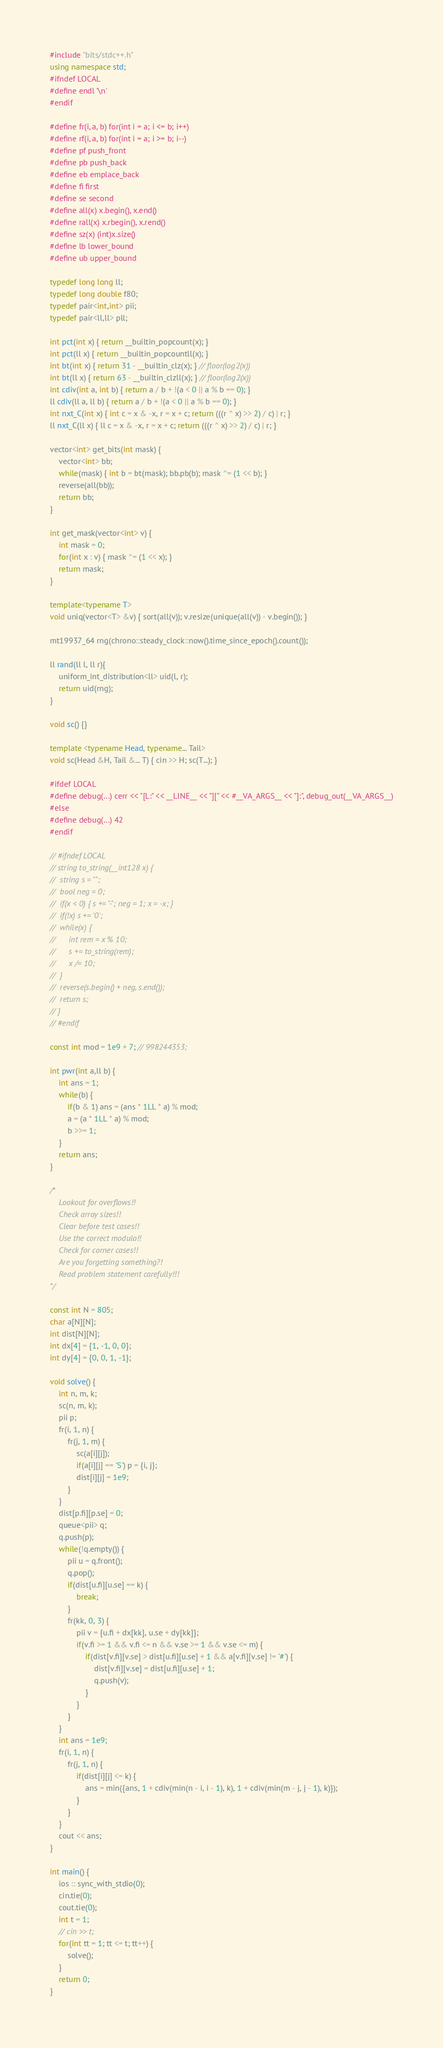Convert code to text. <code><loc_0><loc_0><loc_500><loc_500><_C++_>#include "bits/stdc++.h"
using namespace std;
#ifndef LOCAL
#define endl '\n'
#endif

#define fr(i, a, b) for(int i = a; i <= b; i++)
#define rf(i, a, b) for(int i = a; i >= b; i--)
#define pf push_front
#define pb push_back
#define eb emplace_back
#define fi first
#define se second
#define all(x) x.begin(), x.end()
#define rall(x) x.rbegin(), x.rend()
#define sz(x) (int)x.size()
#define lb lower_bound
#define ub upper_bound

typedef long long ll;
typedef long double f80;
typedef pair<int,int> pii;
typedef pair<ll,ll> pll;

int pct(int x) { return __builtin_popcount(x); }
int pct(ll x) { return __builtin_popcountll(x); }
int bt(int x) { return 31 - __builtin_clz(x); } // floor(log2(x))
int bt(ll x) { return 63 - __builtin_clzll(x); } // floor(log2(x))
int cdiv(int a, int b) { return a / b + !(a < 0 || a % b == 0); }
ll cdiv(ll a, ll b) { return a / b + !(a < 0 || a % b == 0); }
int nxt_C(int x) { int c = x & -x, r = x + c; return (((r ^ x) >> 2) / c) | r; }
ll nxt_C(ll x) { ll c = x & -x, r = x + c; return (((r ^ x) >> 2) / c) | r; }

vector<int> get_bits(int mask) {
	vector<int> bb;
	while(mask) { int b = bt(mask); bb.pb(b); mask ^= (1 << b); }
	reverse(all(bb));
	return bb;
}

int get_mask(vector<int> v) {
	int mask = 0;
	for(int x : v) { mask ^= (1 << x); }
	return mask;
}

template<typename T>
void uniq(vector<T> &v) { sort(all(v)); v.resize(unique(all(v)) - v.begin()); }

mt19937_64 rng(chrono::steady_clock::now().time_since_epoch().count());

ll rand(ll l, ll r){
	uniform_int_distribution<ll> uid(l, r);
	return uid(rng);
}

void sc() {}

template <typename Head, typename... Tail>
void sc(Head &H, Tail &... T) { cin >> H; sc(T...); }

#ifdef LOCAL
#define debug(...) cerr << "[L:" << __LINE__ << "][" << #__VA_ARGS__ << "]:", debug_out(__VA_ARGS__)
#else
#define debug(...) 42
#endif

// #ifndef LOCAL
// string to_string(__int128 x) {
// 	string s = "";
// 	bool neg = 0;
// 	if(x < 0) { s += "-"; neg = 1; x = -x; }
// 	if(!x) s += '0';
// 	while(x) {
// 		int rem = x % 10;
// 		s += to_string(rem);
// 		x /= 10;
// 	}
// 	reverse(s.begin() + neg, s.end());
// 	return s;
// }
// #endif

const int mod = 1e9 + 7; // 998244353;

int pwr(int a,ll b) {
	int ans = 1;
	while(b) {
		if(b & 1) ans = (ans * 1LL * a) % mod;
		a = (a * 1LL * a) % mod;
		b >>= 1;
	}
	return ans;
}

/*
	Lookout for overflows!!
	Check array sizes!!
	Clear before test cases!!
	Use the correct modulo!!
	Check for corner cases!!
	Are you forgetting something?!
	Read problem statement carefully!!!
*/

const int N = 805;
char a[N][N];
int dist[N][N];
int dx[4] = {1, -1, 0, 0};
int dy[4] = {0, 0, 1, -1};

void solve() {
	int n, m, k;
    sc(n, m, k);
    pii p;
    fr(i, 1, n) {
        fr(j, 1, m) {
            sc(a[i][j]);
            if(a[i][j] == 'S') p = {i, j};
            dist[i][j] = 1e9;
        }
    }
    dist[p.fi][p.se] = 0;
    queue<pii> q;
    q.push(p);
    while(!q.empty()) {
        pii u = q.front();
        q.pop();
        if(dist[u.fi][u.se] == k) {
            break;
        }
        fr(kk, 0, 3) {
            pii v = {u.fi + dx[kk], u.se + dy[kk]};
            if(v.fi >= 1 && v.fi <= n && v.se >= 1 && v.se <= m) {
                if(dist[v.fi][v.se] > dist[u.fi][u.se] + 1 && a[v.fi][v.se] != '#') {
                    dist[v.fi][v.se] = dist[u.fi][u.se] + 1;
                    q.push(v);
                }
            }
        }
    }
    int ans = 1e9;
    fr(i, 1, n) {
        fr(j, 1, n) {
            if(dist[i][j] <= k) {
                ans = min({ans, 1 + cdiv(min(n - i, i - 1), k), 1 + cdiv(min(m - j, j - 1), k)});
            }
        }
    }
    cout << ans;
}

int main() {
	ios :: sync_with_stdio(0);
	cin.tie(0);
	cout.tie(0);
	int t = 1;
	// cin >> t;
	for(int tt = 1; tt <= t; tt++) {
		solve();
	}
	return 0;
}</code> 